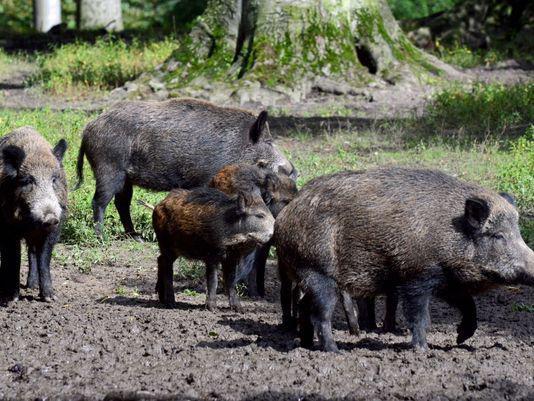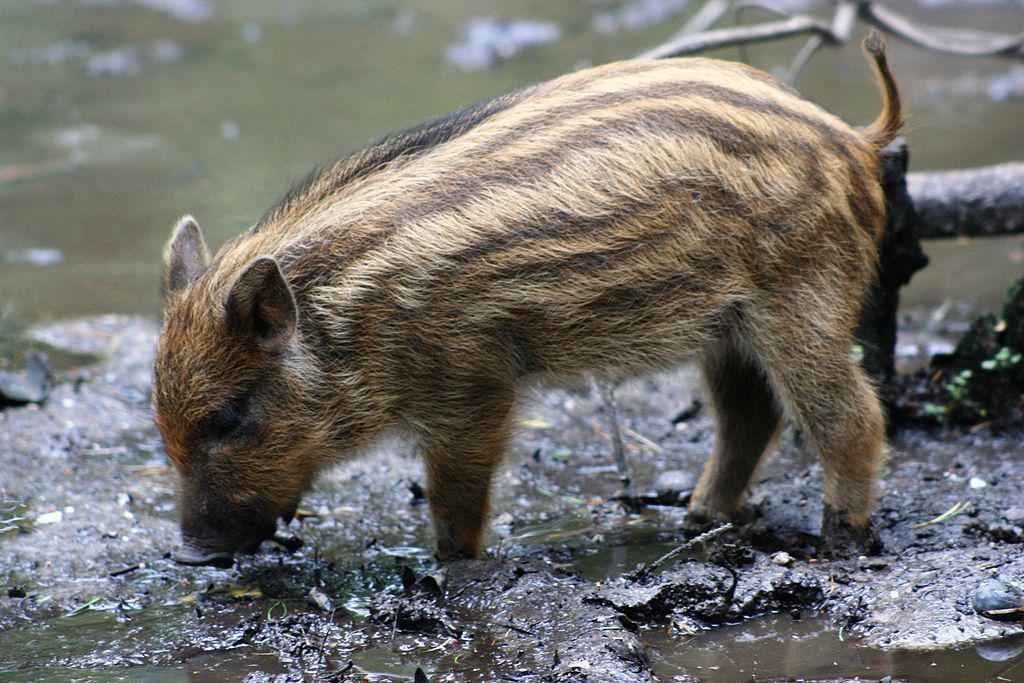The first image is the image on the left, the second image is the image on the right. Analyze the images presented: Is the assertion "Each image includes a pair of animals facing-off aggressively, and the right image features a boar with its mouth open baring fangs." valid? Answer yes or no. No. The first image is the image on the left, the second image is the image on the right. Analyze the images presented: Is the assertion "There is a single animal in the right image." valid? Answer yes or no. Yes. 